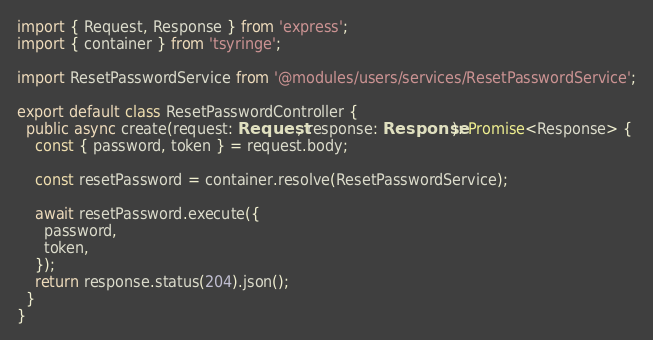Convert code to text. <code><loc_0><loc_0><loc_500><loc_500><_TypeScript_>import { Request, Response } from 'express';
import { container } from 'tsyringe';

import ResetPasswordService from '@modules/users/services/ResetPasswordService';

export default class ResetPasswordController {
  public async create(request: Request, response: Response): Promise<Response> {
    const { password, token } = request.body;

    const resetPassword = container.resolve(ResetPasswordService);

    await resetPassword.execute({
      password,
      token,
    });
    return response.status(204).json();
  }
}
</code> 